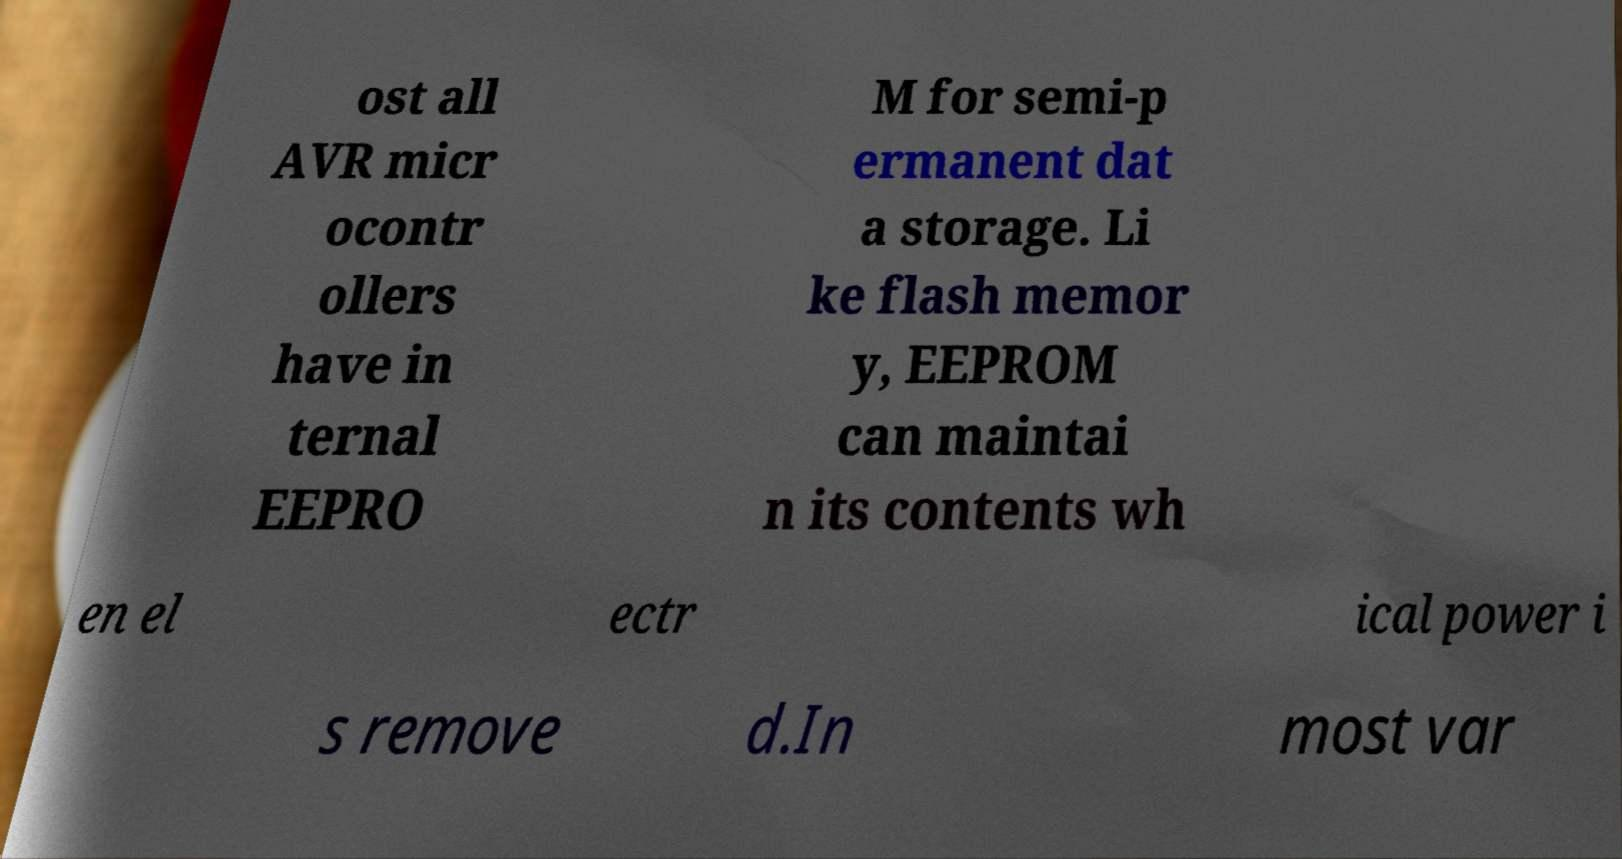There's text embedded in this image that I need extracted. Can you transcribe it verbatim? ost all AVR micr ocontr ollers have in ternal EEPRO M for semi-p ermanent dat a storage. Li ke flash memor y, EEPROM can maintai n its contents wh en el ectr ical power i s remove d.In most var 